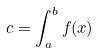<formula> <loc_0><loc_0><loc_500><loc_500>c = \int _ { a } ^ { b } f ( x )</formula> 